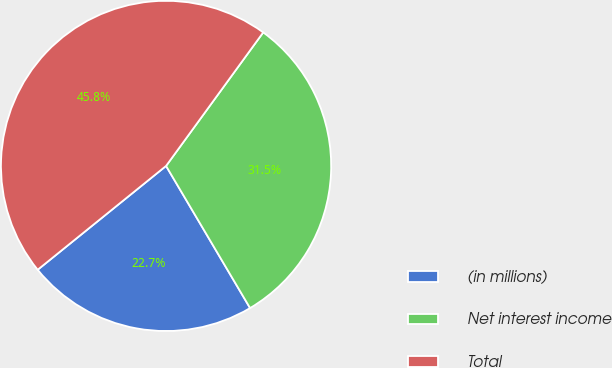Convert chart. <chart><loc_0><loc_0><loc_500><loc_500><pie_chart><fcel>(in millions)<fcel>Net interest income<fcel>Total<nl><fcel>22.67%<fcel>31.49%<fcel>45.83%<nl></chart> 